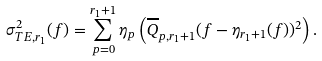Convert formula to latex. <formula><loc_0><loc_0><loc_500><loc_500>\sigma ^ { 2 } _ { T E , r _ { 1 } } ( f ) = \sum _ { p = 0 } ^ { r _ { 1 } + 1 } \eta _ { p } \left ( \overline { Q } _ { p , r _ { 1 } + 1 } ( f - \eta _ { r _ { 1 } + 1 } ( f ) ) ^ { 2 } \right ) .</formula> 